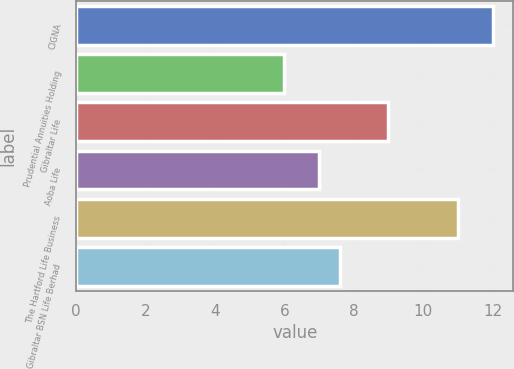<chart> <loc_0><loc_0><loc_500><loc_500><bar_chart><fcel>CIGNA<fcel>Prudential Annuities Holding<fcel>Gibraltar Life<fcel>Aoba Life<fcel>The Hartford Life Business<fcel>Gibraltar BSN Life Berhad<nl><fcel>12<fcel>6<fcel>9<fcel>7<fcel>11<fcel>7.6<nl></chart> 